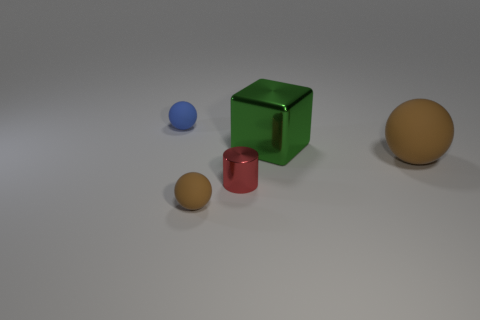What is the size of the green metal cube?
Make the answer very short. Large. What size is the brown ball that is made of the same material as the small brown object?
Your response must be concise. Large. How many objects are large green shiny objects or small matte things in front of the big brown ball?
Your answer should be very brief. 2. There is a brown rubber object that is in front of the tiny metallic cylinder; what size is it?
Your response must be concise. Small. There is a matte object that is the same color as the large ball; what is its shape?
Offer a terse response. Sphere. Do the red object and the brown sphere on the left side of the big block have the same material?
Offer a very short reply. No. There is a object left of the tiny rubber object in front of the tiny blue matte ball; what number of big shiny things are right of it?
Make the answer very short. 1. How many gray objects are tiny balls or small cylinders?
Your answer should be very brief. 0. What shape is the red metal thing that is in front of the blue ball?
Ensure brevity in your answer.  Cylinder. What is the color of the matte ball that is the same size as the metallic block?
Provide a short and direct response. Brown. 